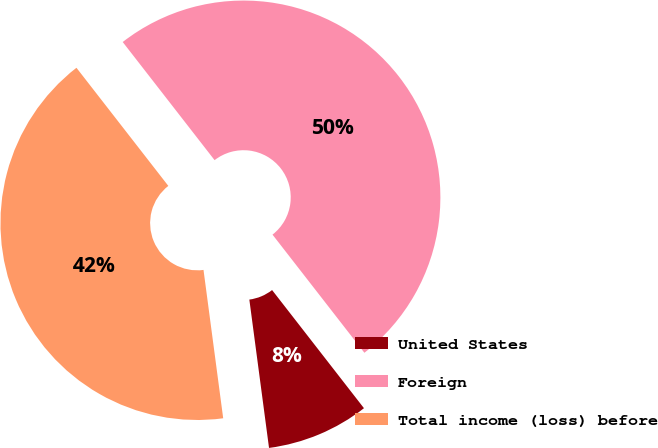Convert chart to OTSL. <chart><loc_0><loc_0><loc_500><loc_500><pie_chart><fcel>United States<fcel>Foreign<fcel>Total income (loss) before<nl><fcel>8.42%<fcel>50.0%<fcel>41.58%<nl></chart> 